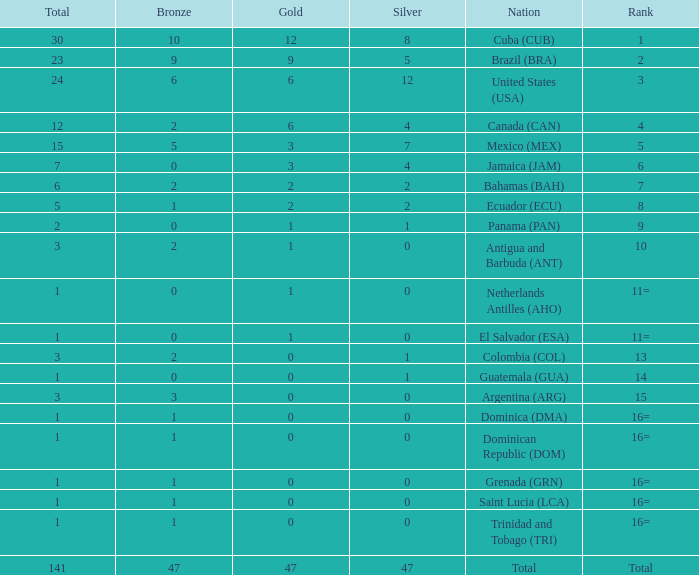How many bronzes have a Nation of jamaica (jam), and a Total smaller than 7? 0.0. 